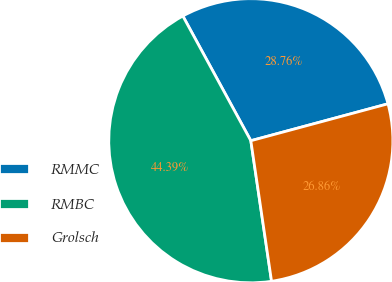Convert chart to OTSL. <chart><loc_0><loc_0><loc_500><loc_500><pie_chart><fcel>RMMC<fcel>RMBC<fcel>Grolsch<nl><fcel>28.76%<fcel>44.39%<fcel>26.86%<nl></chart> 